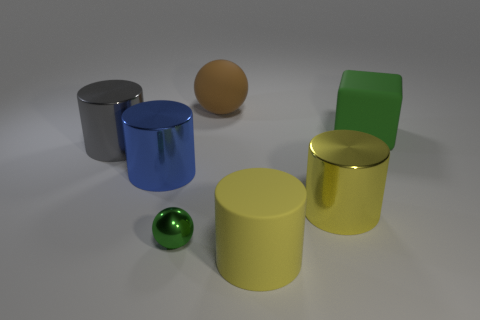How many things are either cyan cylinders or big metal objects that are behind the large blue thing?
Give a very brief answer. 1. How many other things are there of the same size as the blue object?
Keep it short and to the point. 5. There is a large thing that is the same shape as the small metal thing; what is its material?
Provide a succinct answer. Rubber. Are there more green rubber objects that are in front of the large yellow rubber thing than shiny balls?
Make the answer very short. No. Is there anything else that is the same color as the block?
Your answer should be very brief. Yes. What is the shape of the tiny green object that is made of the same material as the blue cylinder?
Provide a succinct answer. Sphere. Does the ball that is in front of the large rubber ball have the same material as the large green cube?
Your answer should be very brief. No. There is a tiny thing that is the same color as the large matte cube; what shape is it?
Your answer should be very brief. Sphere. There is a big shiny object on the right side of the brown rubber thing; does it have the same color as the object in front of the small metallic thing?
Your response must be concise. Yes. What number of big rubber objects are both to the right of the large brown object and behind the large yellow rubber object?
Offer a terse response. 1. 